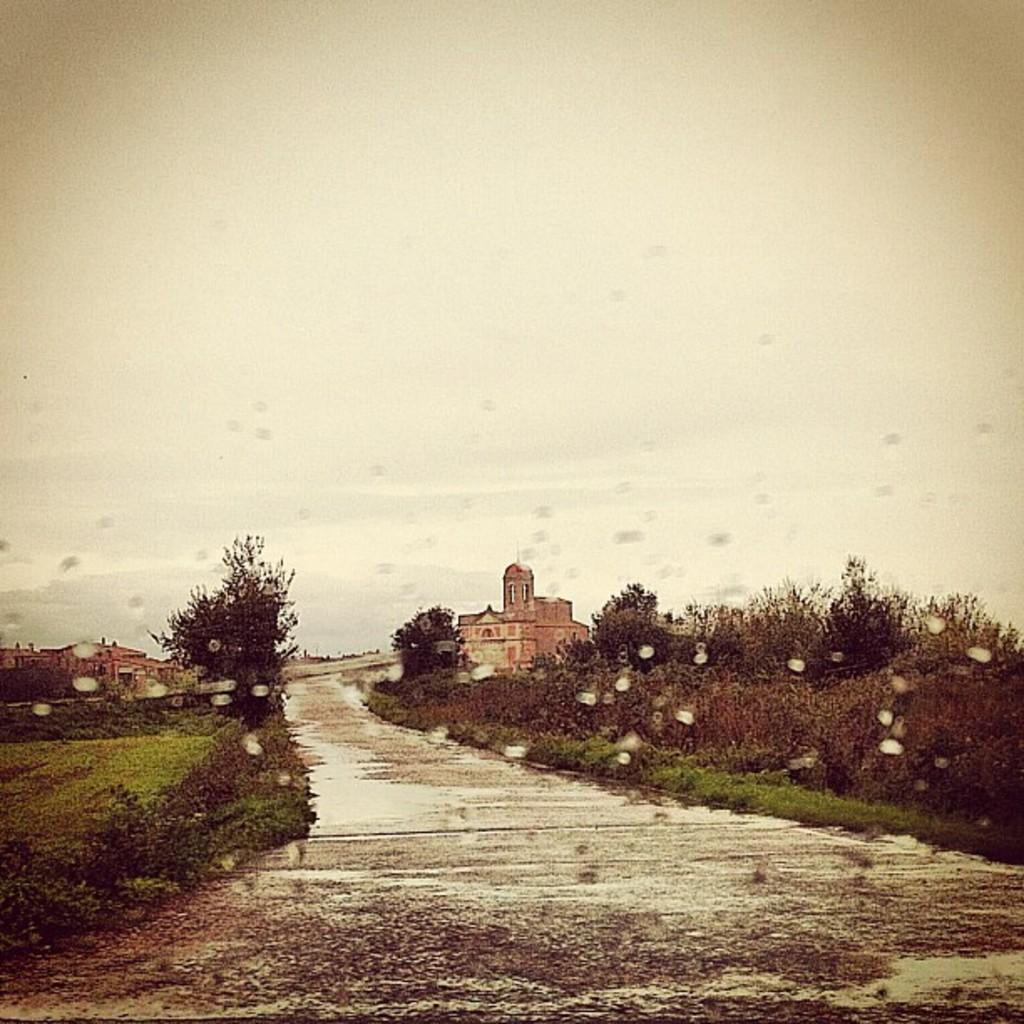What is the main feature of the image? There is a road in the image. What can be seen on the left side of the image? Plants are visible on the left side of the image. What can be seen on the right side of the image? Plants are visible on the right side of the image. What is visible in the background of the image? There are buildings in the background of the image. What is visible at the top of the image? The sky is visible at the top of the image. What year is depicted in the image? The image does not depict a specific year; it is a general scene of a road, plants, buildings, and sky. Can you tell me how many people are driving in the image? There are no people or vehicles visible in the image, so it is not possible to determine how many people might be driving. 